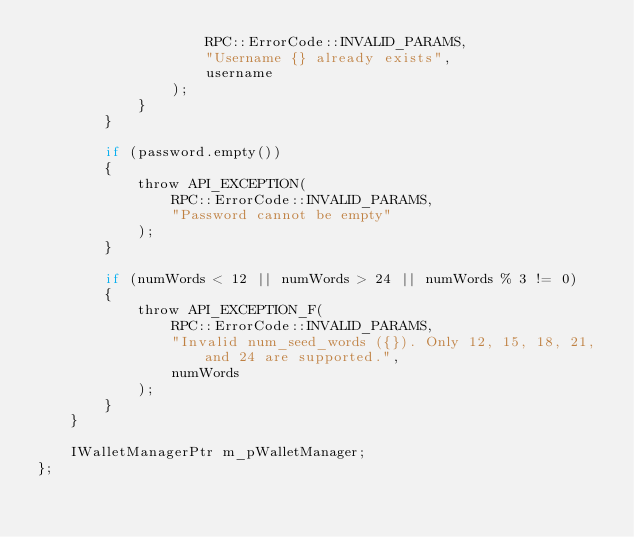<code> <loc_0><loc_0><loc_500><loc_500><_C_>					RPC::ErrorCode::INVALID_PARAMS,
					"Username {} already exists",
					username
				);
			}
		}

		if (password.empty())
		{
			throw API_EXCEPTION(
				RPC::ErrorCode::INVALID_PARAMS,
				"Password cannot be empty"
			);
		}

		if (numWords < 12 || numWords > 24 || numWords % 3 != 0)
		{
			throw API_EXCEPTION_F(
				RPC::ErrorCode::INVALID_PARAMS,
				"Invalid num_seed_words ({}). Only 12, 15, 18, 21, and 24 are supported.",
				numWords
			);
		}
	}

	IWalletManagerPtr m_pWalletManager;
};</code> 